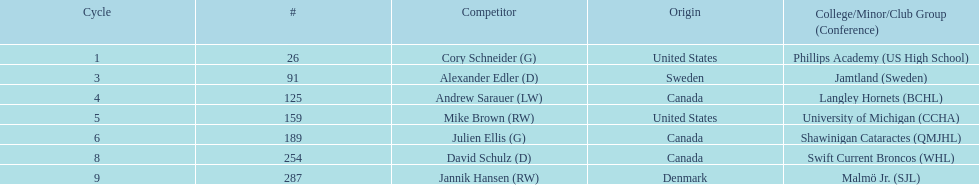Which player has canadian nationality and attended langley hornets? Andrew Sarauer (LW). 